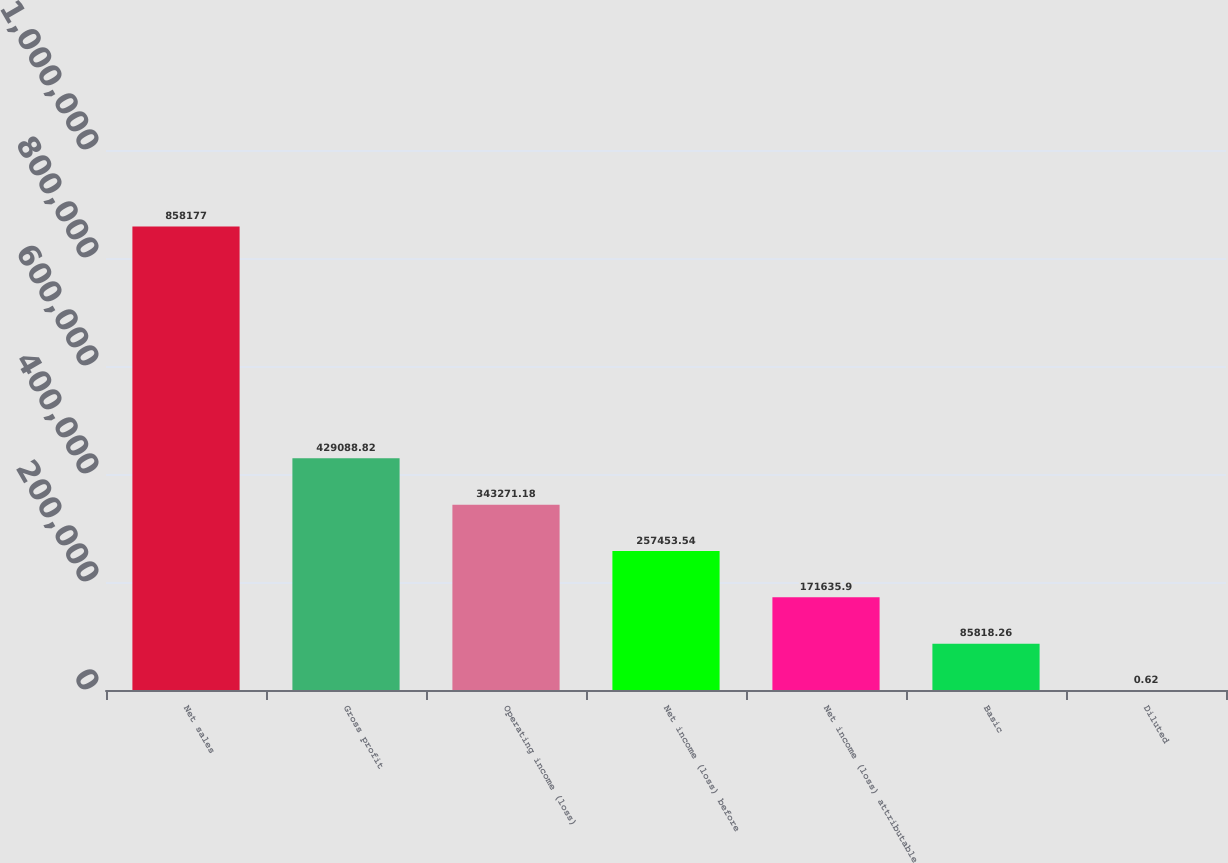Convert chart. <chart><loc_0><loc_0><loc_500><loc_500><bar_chart><fcel>Net sales<fcel>Gross profit<fcel>Operating income (loss)<fcel>Net income (loss) before<fcel>Net income (loss) attributable<fcel>Basic<fcel>Diluted<nl><fcel>858177<fcel>429089<fcel>343271<fcel>257454<fcel>171636<fcel>85818.3<fcel>0.62<nl></chart> 